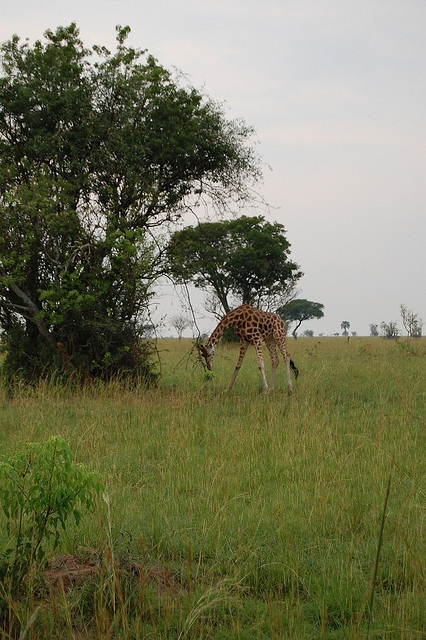Describe the objects in this image and their specific colors. I can see a giraffe in lightgray, olive, black, gray, and maroon tones in this image. 